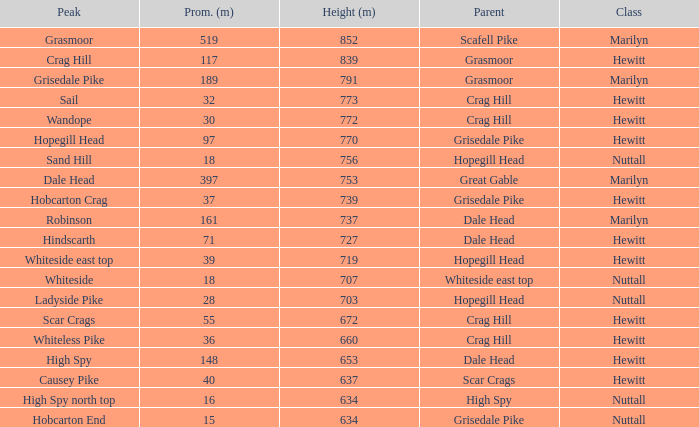Which Class is Peak Sail when it has a Prom larger than 30? Hewitt. 